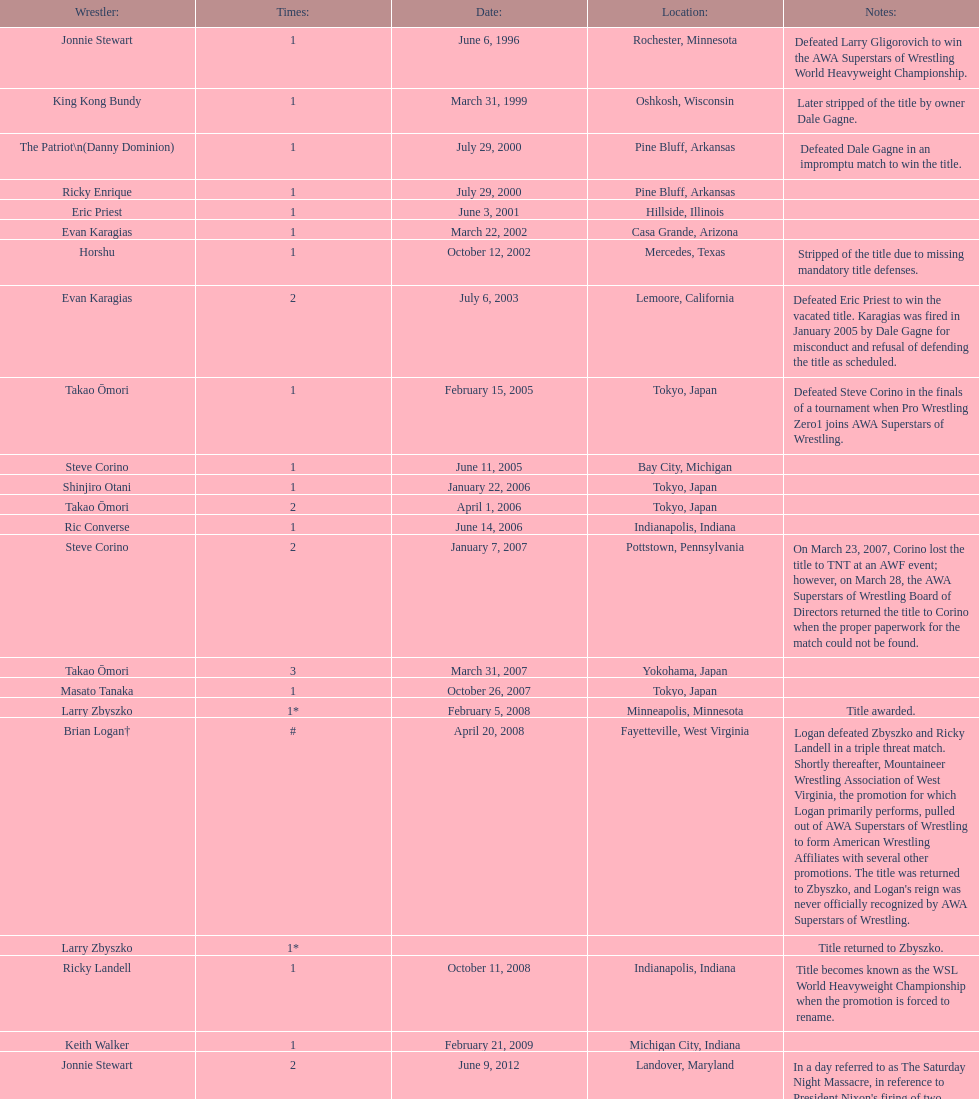How many times has ricky landell held the wsl title? 1. 